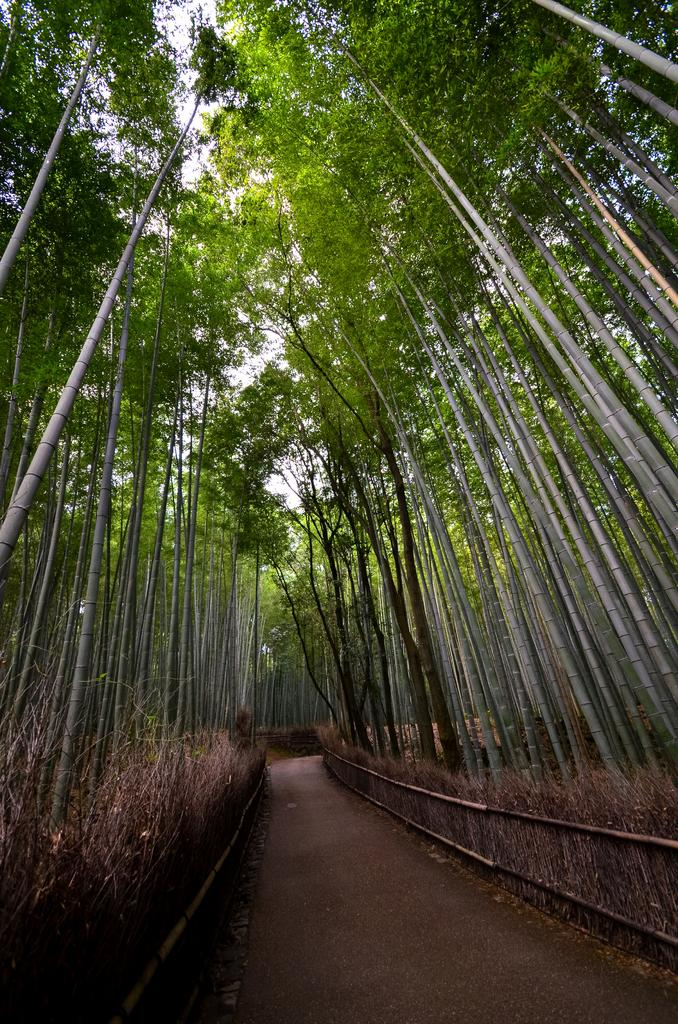What type of surface can be seen in the image? There is a path in the image. What is used to enclose or separate areas in the image? There is fencing in the image. What type of vegetation is present in the image? There is grass in the image. What type of natural structures are visible in the image? There are trees in the image. What is visible above the ground in the image? The sky is visible in the image. Where is the hole located in the image? There is no hole present in the image. What type of man can be seen in the image? There are no people, including men, present in the image. 